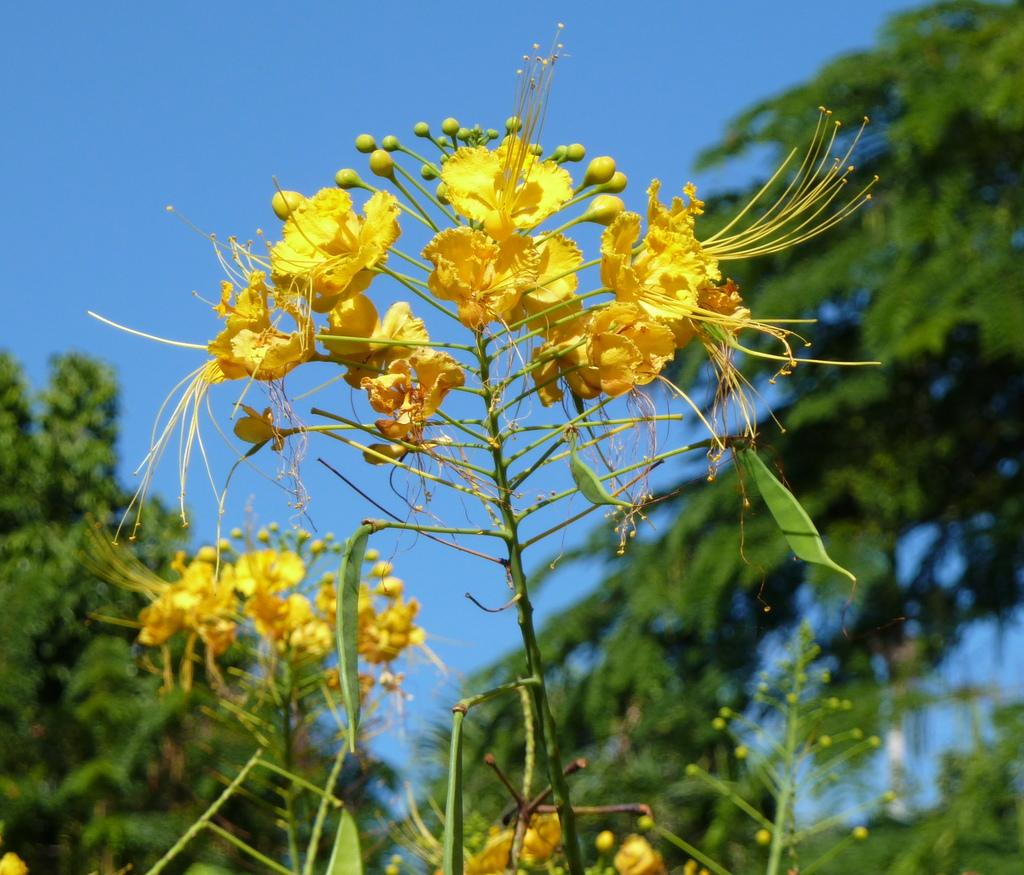What type of flora is present in the image? There are flowers in the image. What type of fauna can be seen in the image? There are yellow birds in the image. What type of vegetation is on either side of the image? There are trees on either side of the image. What is visible at the top of the image? The sky is visible at the top of the image. What type of vessel is present in the image? There is no vessel present in the image. 